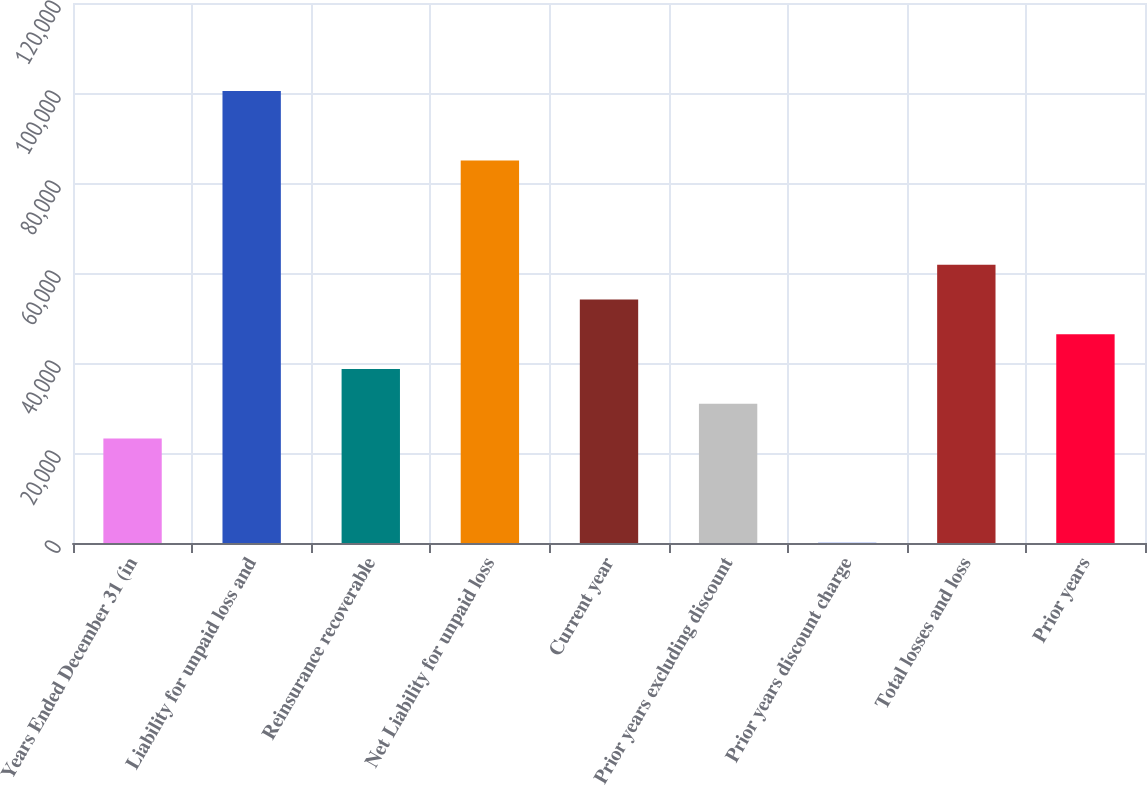<chart> <loc_0><loc_0><loc_500><loc_500><bar_chart><fcel>Years Ended December 31 (in<fcel>Liability for unpaid loss and<fcel>Reinsurance recoverable<fcel>Net Liability for unpaid loss<fcel>Current year<fcel>Prior years excluding discount<fcel>Prior years discount charge<fcel>Total losses and loss<fcel>Prior years<nl><fcel>23227.7<fcel>100417<fcel>38665.5<fcel>84978.9<fcel>54103.3<fcel>30946.6<fcel>71<fcel>61822.2<fcel>46384.4<nl></chart> 